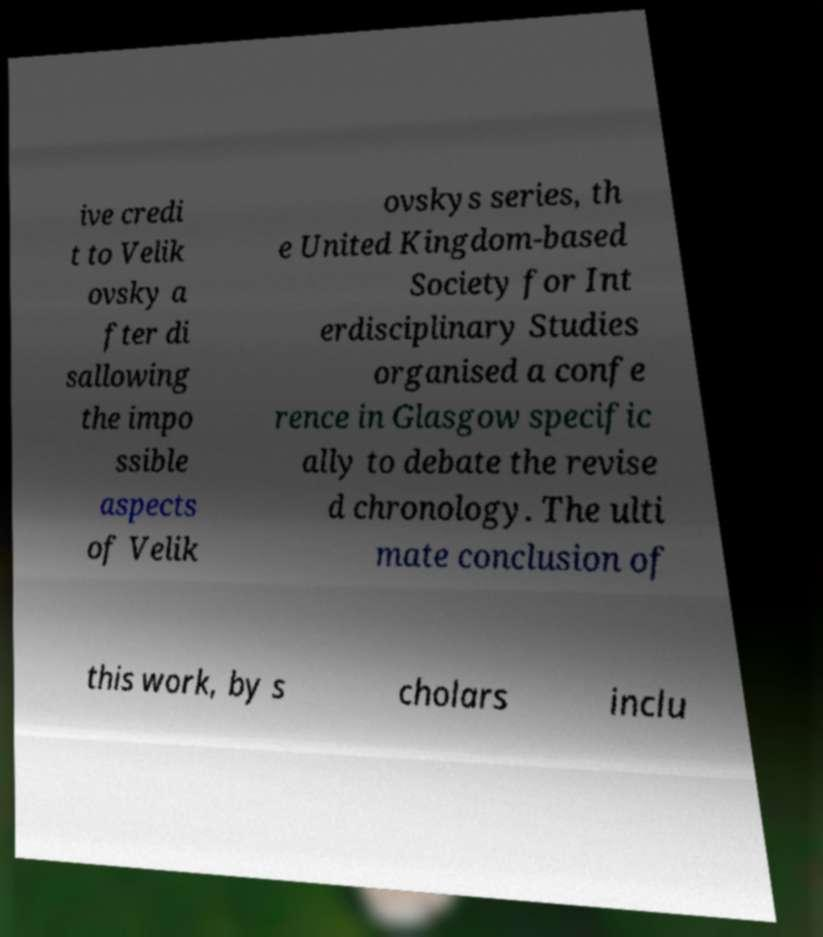What messages or text are displayed in this image? I need them in a readable, typed format. ive credi t to Velik ovsky a fter di sallowing the impo ssible aspects of Velik ovskys series, th e United Kingdom-based Society for Int erdisciplinary Studies organised a confe rence in Glasgow specific ally to debate the revise d chronology. The ulti mate conclusion of this work, by s cholars inclu 